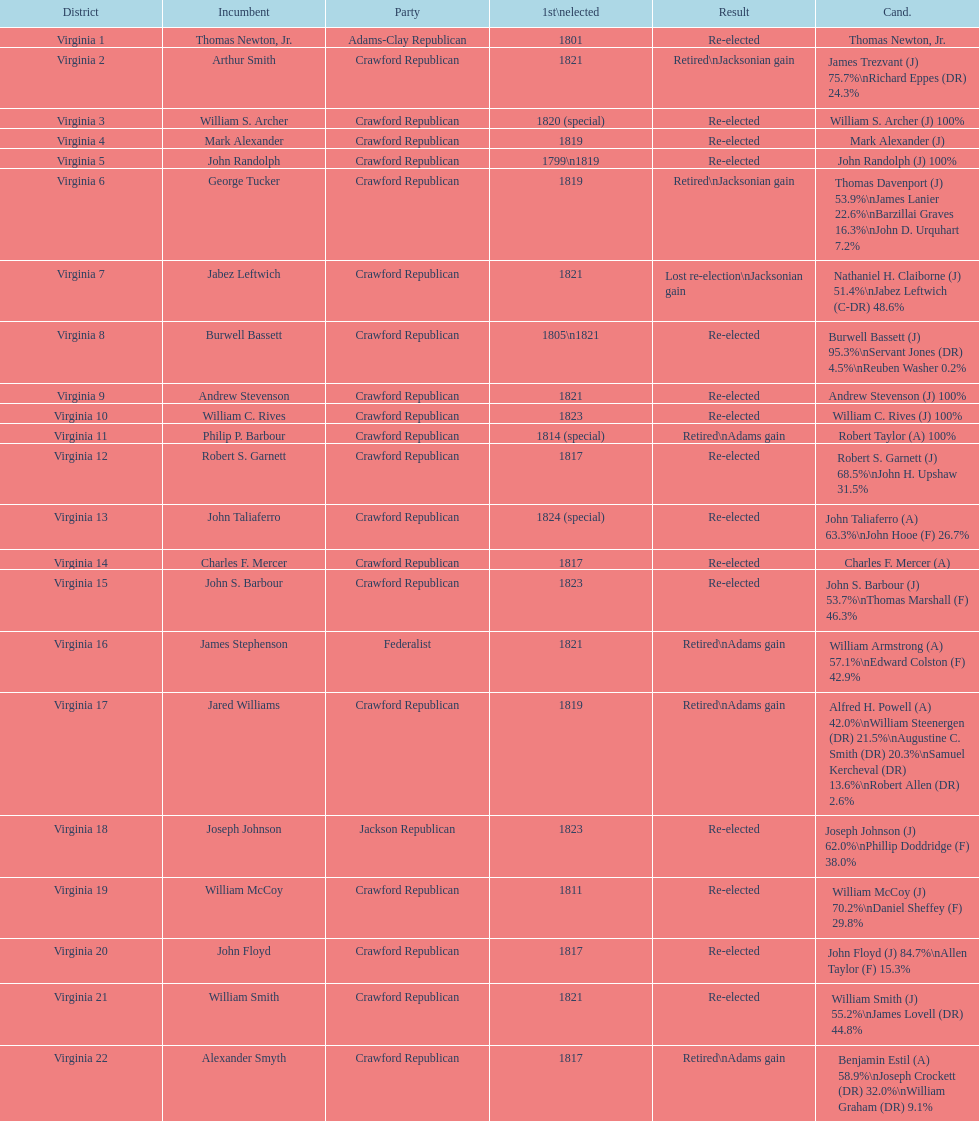What are the number of times re-elected is listed as the result? 15. 